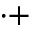Convert formula to latex. <formula><loc_0><loc_0><loc_500><loc_500>^ { \cdot + }</formula> 